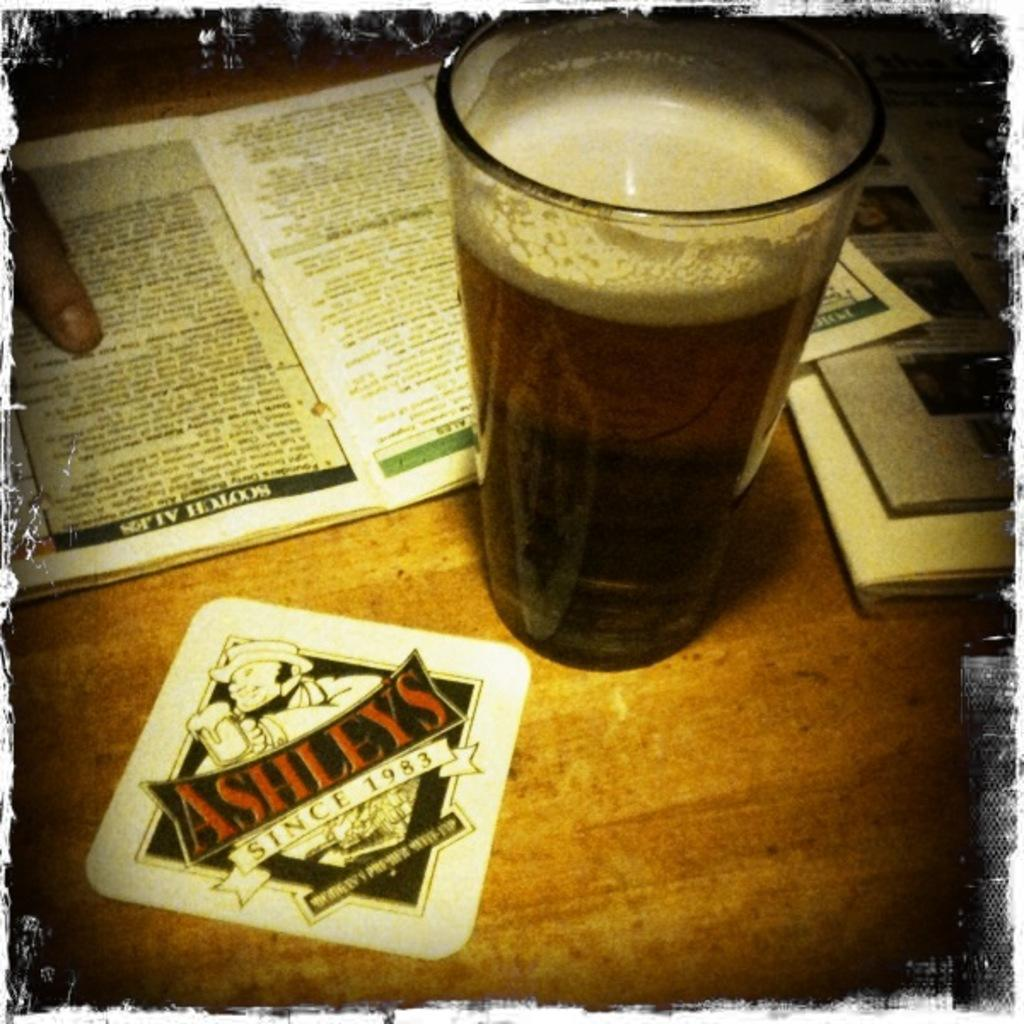Provide a one-sentence caption for the provided image. A table at a restaurant, showing a beer, a person pointing at a menu and a coaster that says Ashley's since 1983. 